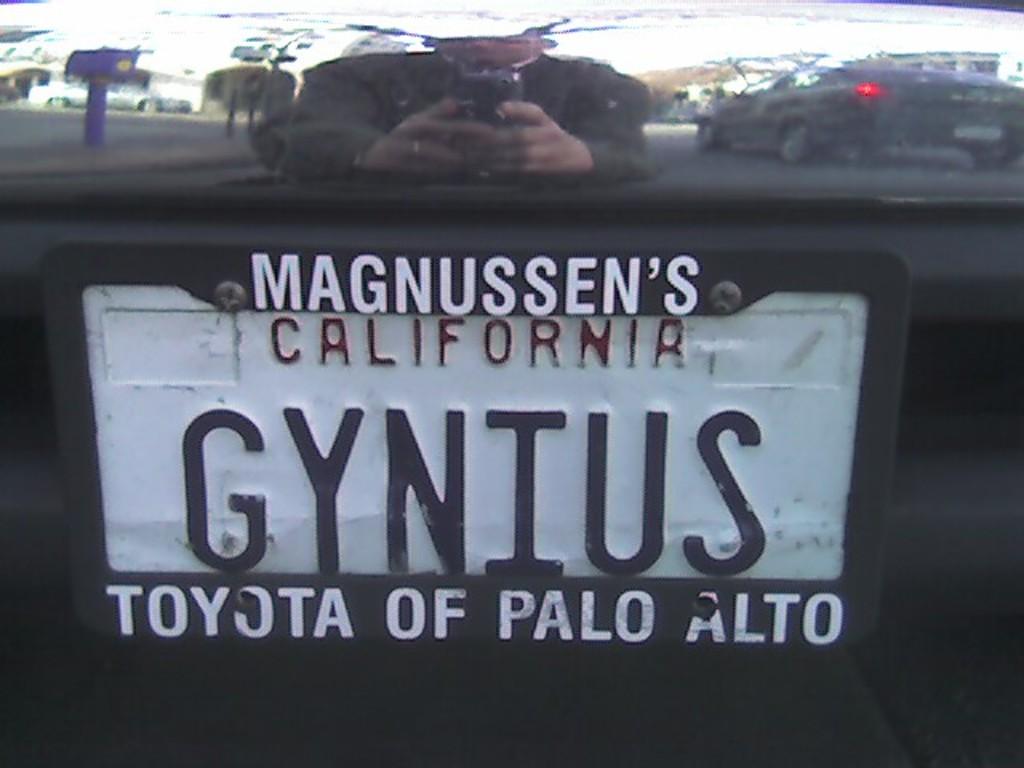What state is on the plate?
Offer a terse response. California. 